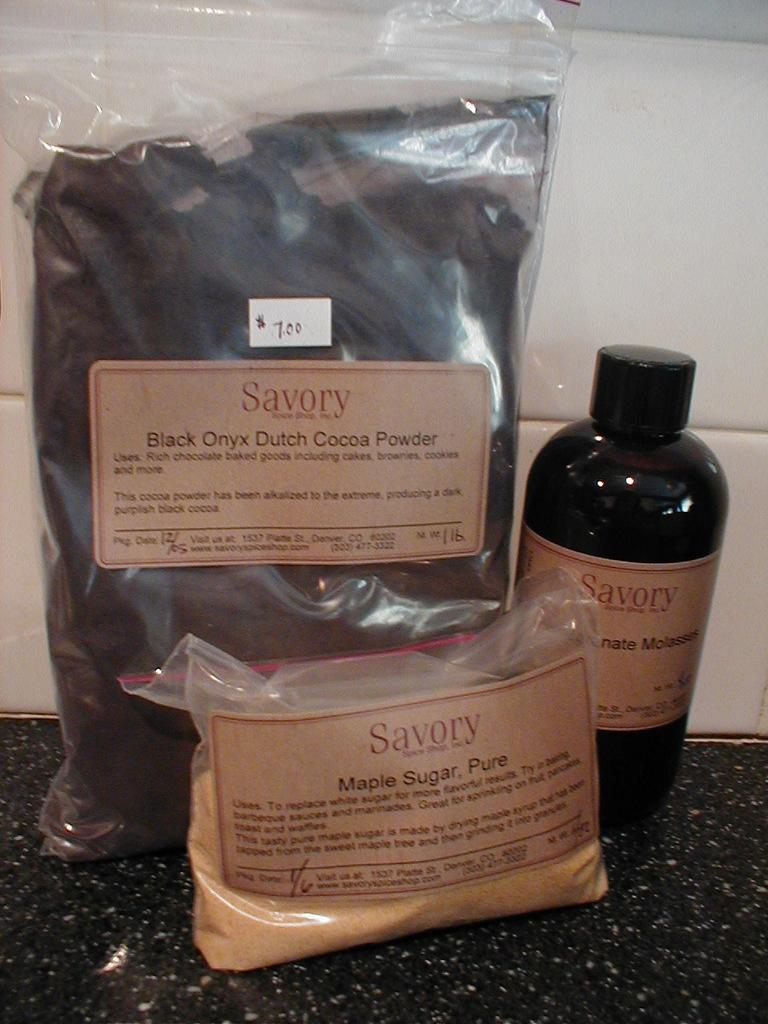<image>
Render a clear and concise summary of the photo. Two bags of Savory brand spices and a bottle of Savory molasses. 